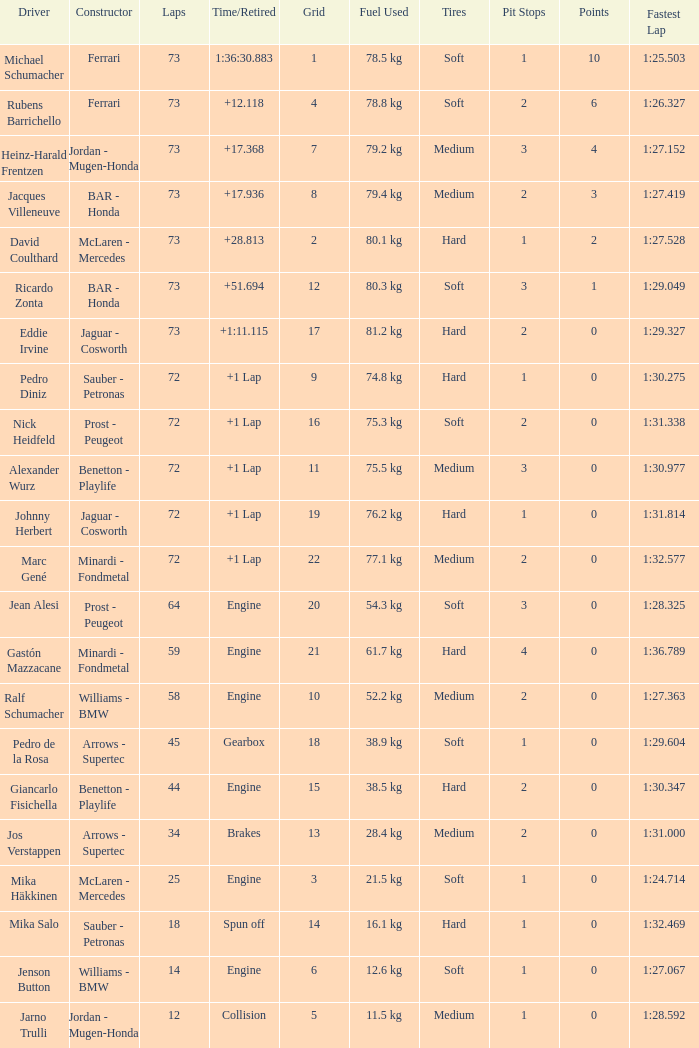How many laps did Jos Verstappen do on Grid 2? 34.0. 